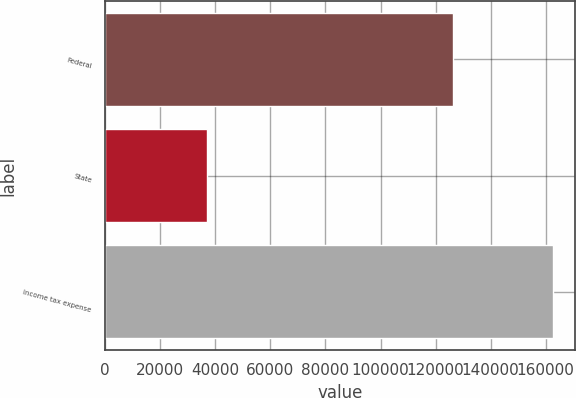Convert chart to OTSL. <chart><loc_0><loc_0><loc_500><loc_500><bar_chart><fcel>Federal<fcel>State<fcel>Income tax expense<nl><fcel>126358<fcel>37038<fcel>162535<nl></chart> 